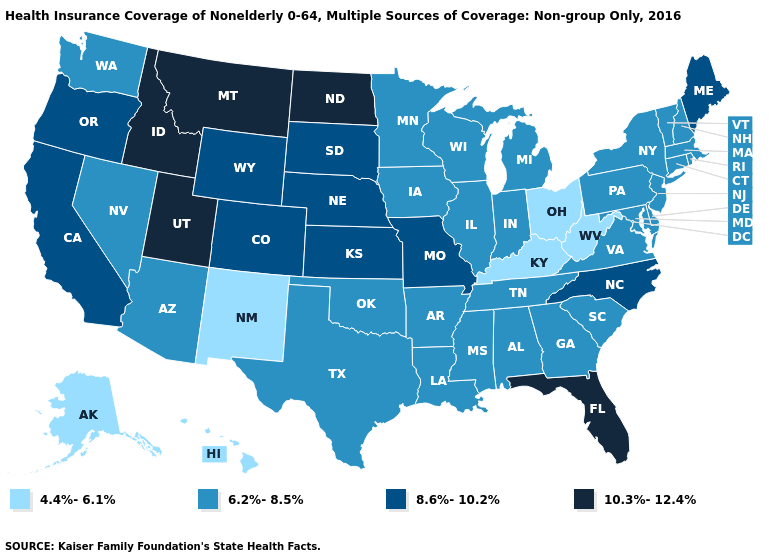Does North Dakota have the highest value in the USA?
Answer briefly. Yes. What is the value of Oregon?
Quick response, please. 8.6%-10.2%. What is the lowest value in the USA?
Write a very short answer. 4.4%-6.1%. Does the map have missing data?
Short answer required. No. Among the states that border New Jersey , which have the highest value?
Concise answer only. Delaware, New York, Pennsylvania. What is the highest value in the USA?
Short answer required. 10.3%-12.4%. What is the lowest value in the MidWest?
Give a very brief answer. 4.4%-6.1%. What is the value of Tennessee?
Quick response, please. 6.2%-8.5%. Does Massachusetts have the lowest value in the Northeast?
Short answer required. Yes. Which states have the lowest value in the Northeast?
Keep it brief. Connecticut, Massachusetts, New Hampshire, New Jersey, New York, Pennsylvania, Rhode Island, Vermont. Does Ohio have the highest value in the USA?
Keep it brief. No. Does Florida have the highest value in the South?
Quick response, please. Yes. Which states have the lowest value in the West?
Give a very brief answer. Alaska, Hawaii, New Mexico. 